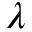Convert formula to latex. <formula><loc_0><loc_0><loc_500><loc_500>\lambda</formula> 